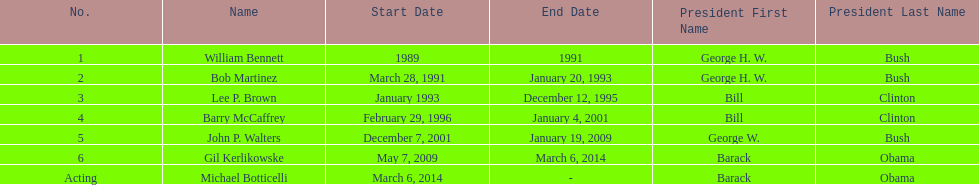How long did bob martinez serve as director? 2 years. 